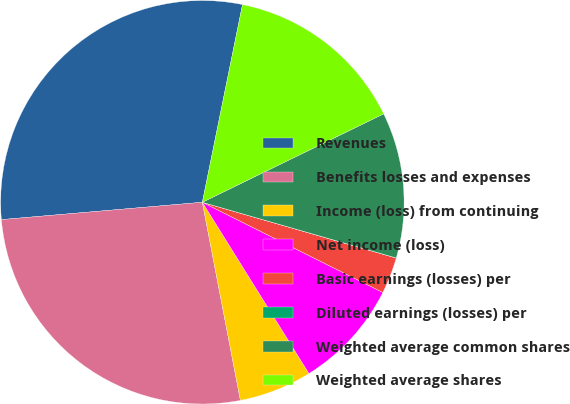<chart> <loc_0><loc_0><loc_500><loc_500><pie_chart><fcel>Revenues<fcel>Benefits losses and expenses<fcel>Income (loss) from continuing<fcel>Net income (loss)<fcel>Basic earnings (losses) per<fcel>Diluted earnings (losses) per<fcel>Weighted average common shares<fcel>Weighted average shares<nl><fcel>29.56%<fcel>26.65%<fcel>5.84%<fcel>8.76%<fcel>2.92%<fcel>0.01%<fcel>11.67%<fcel>14.59%<nl></chart> 